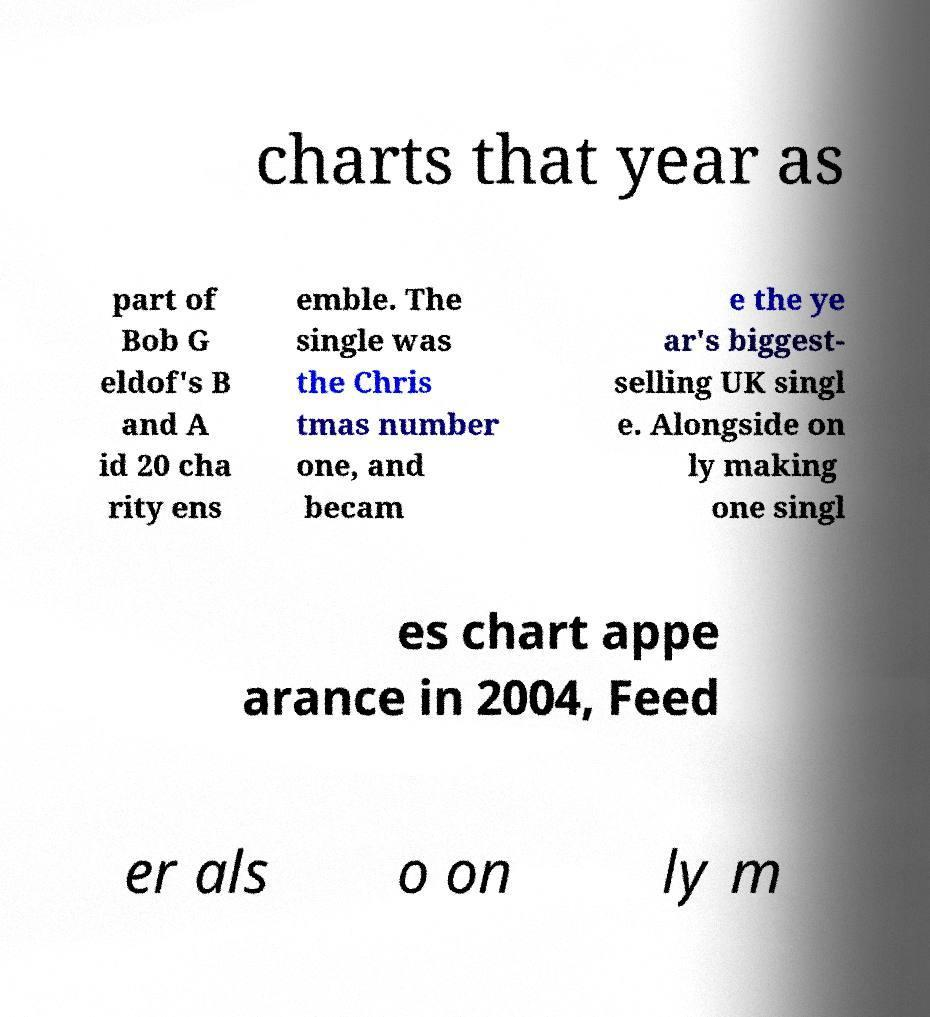I need the written content from this picture converted into text. Can you do that? charts that year as part of Bob G eldof's B and A id 20 cha rity ens emble. The single was the Chris tmas number one, and becam e the ye ar's biggest- selling UK singl e. Alongside on ly making one singl es chart appe arance in 2004, Feed er als o on ly m 